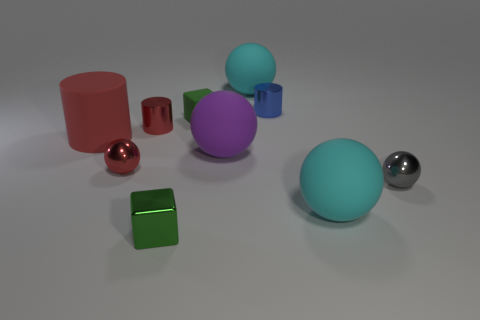What number of large things are either cylinders or rubber cylinders? In the provided image, we have a variety of geometric shapes, of which two appear to be large cylinders: one is a bright red cylinder standing vertically, and the other is a smaller, darker crimson cylinder lying horizontally. 